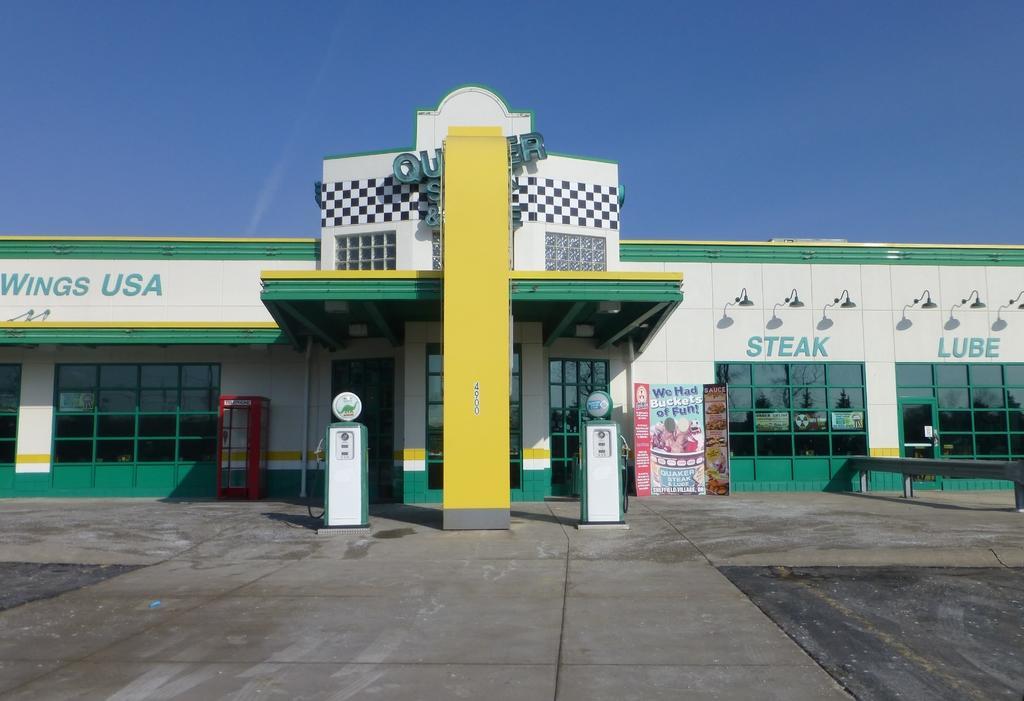Describe this image in one or two sentences. In this image I can see the petrol bunk. In-front of the building I can see two fuel containers which are in white and green color. And the building is in white, green and yellow color. In the back I can see the blue sky and I can also see the boards in the front. 